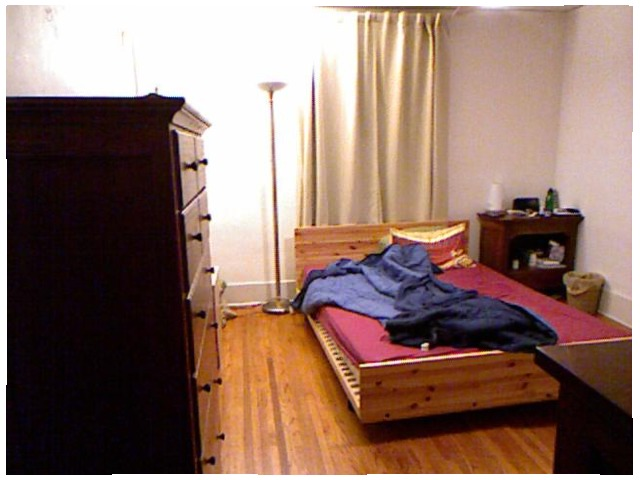<image>
Is there a cloth on the bed? Yes. Looking at the image, I can see the cloth is positioned on top of the bed, with the bed providing support. Is there a dresser to the right of the bed? No. The dresser is not to the right of the bed. The horizontal positioning shows a different relationship. Is there a lamp next to the curtain? Yes. The lamp is positioned adjacent to the curtain, located nearby in the same general area. 